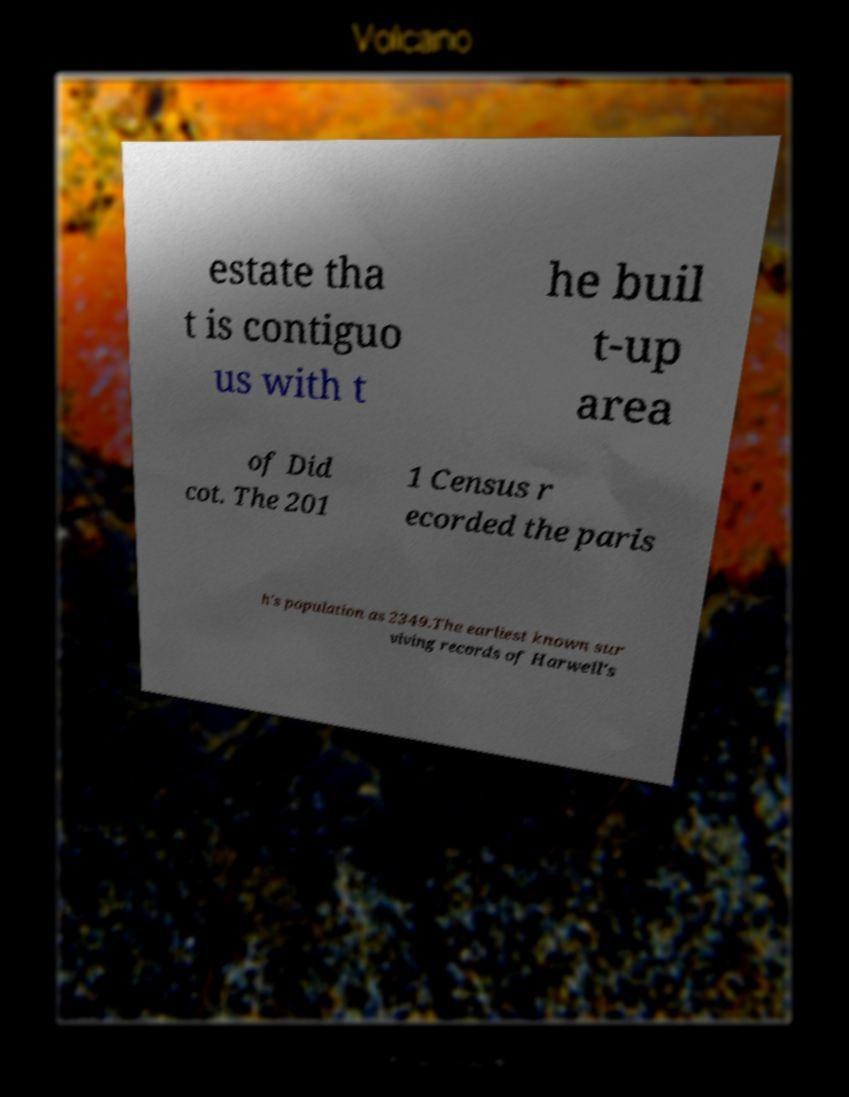For documentation purposes, I need the text within this image transcribed. Could you provide that? estate tha t is contiguo us with t he buil t-up area of Did cot. The 201 1 Census r ecorded the paris h's population as 2349.The earliest known sur viving records of Harwell's 